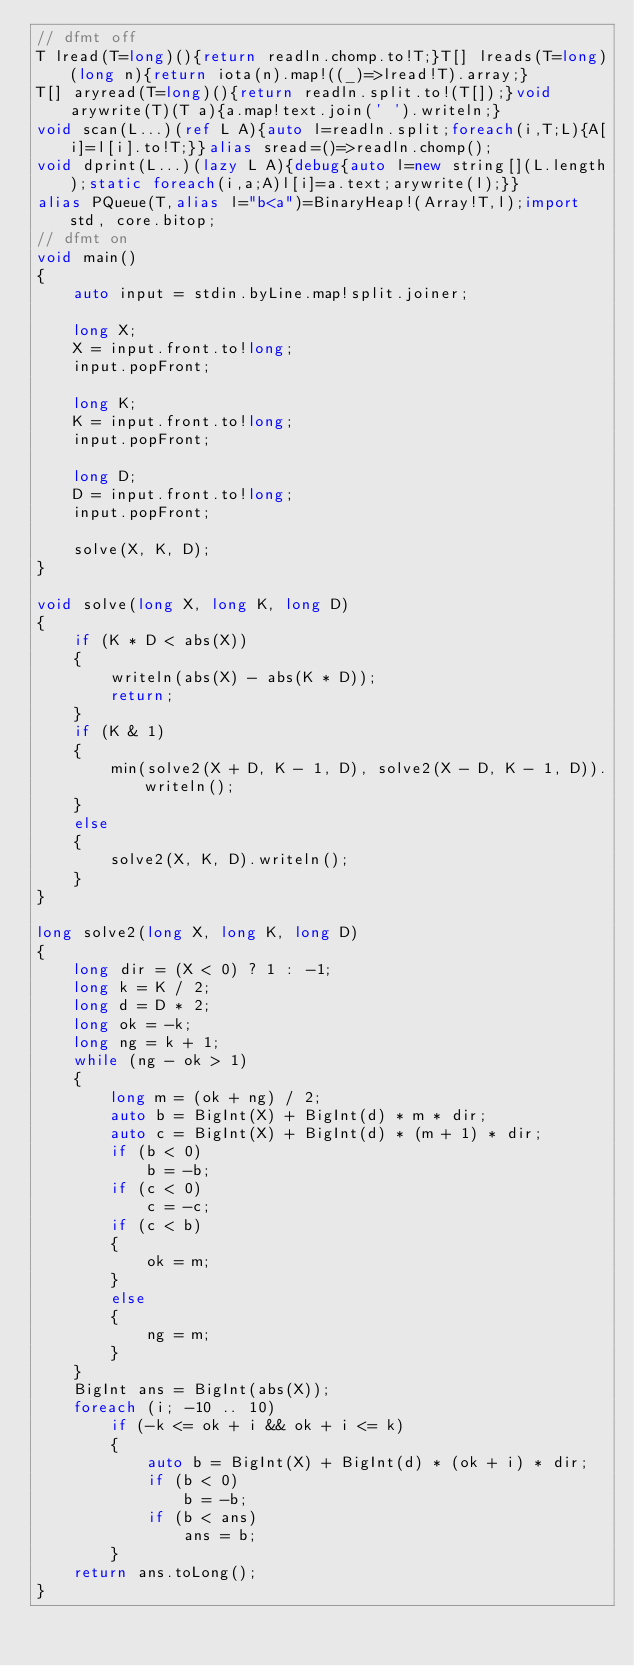Convert code to text. <code><loc_0><loc_0><loc_500><loc_500><_D_>// dfmt off
T lread(T=long)(){return readln.chomp.to!T;}T[] lreads(T=long)(long n){return iota(n).map!((_)=>lread!T).array;}
T[] aryread(T=long)(){return readln.split.to!(T[]);}void arywrite(T)(T a){a.map!text.join(' ').writeln;}
void scan(L...)(ref L A){auto l=readln.split;foreach(i,T;L){A[i]=l[i].to!T;}}alias sread=()=>readln.chomp();
void dprint(L...)(lazy L A){debug{auto l=new string[](L.length);static foreach(i,a;A)l[i]=a.text;arywrite(l);}}
alias PQueue(T,alias l="b<a")=BinaryHeap!(Array!T,l);import std, core.bitop;
// dfmt on
void main()
{
    auto input = stdin.byLine.map!split.joiner;

    long X;
    X = input.front.to!long;
    input.popFront;

    long K;
    K = input.front.to!long;
    input.popFront;

    long D;
    D = input.front.to!long;
    input.popFront;

    solve(X, K, D);
}

void solve(long X, long K, long D)
{
    if (K * D < abs(X))
    {
        writeln(abs(X) - abs(K * D));
        return;
    }
    if (K & 1)
    {
        min(solve2(X + D, K - 1, D), solve2(X - D, K - 1, D)).writeln();
    }
    else
    {
        solve2(X, K, D).writeln();
    }
}

long solve2(long X, long K, long D)
{
    long dir = (X < 0) ? 1 : -1;
    long k = K / 2;
    long d = D * 2;
    long ok = -k;
    long ng = k + 1;
    while (ng - ok > 1)
    {
        long m = (ok + ng) / 2;
        auto b = BigInt(X) + BigInt(d) * m * dir;
        auto c = BigInt(X) + BigInt(d) * (m + 1) * dir;
        if (b < 0)
            b = -b;
        if (c < 0)
            c = -c;
        if (c < b)
        {
            ok = m;
        }
        else
        {
            ng = m;
        }
    }
    BigInt ans = BigInt(abs(X));
    foreach (i; -10 .. 10)
        if (-k <= ok + i && ok + i <= k)
        {
            auto b = BigInt(X) + BigInt(d) * (ok + i) * dir;
            if (b < 0)
                b = -b;
            if (b < ans)
                ans = b;
        }
    return ans.toLong();
}
</code> 